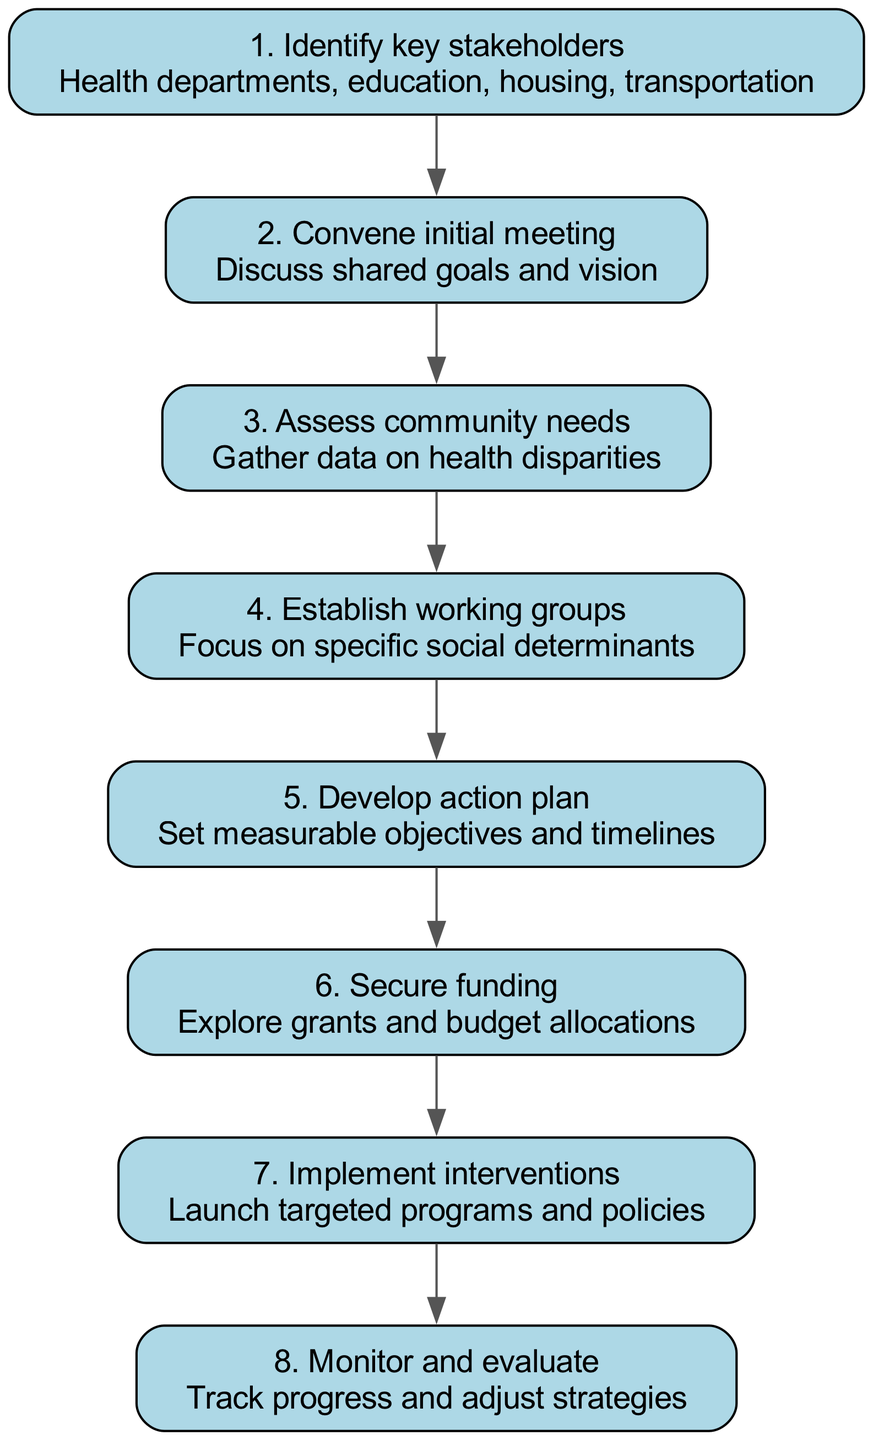What is the first step in the diagram? The first step, identified in the diagram, is labeled as step 1 and states "Identify key stakeholders."
Answer: Identify key stakeholders How many total steps are presented in the flow chart? The diagram outlines a total of 8 steps, from step 1 to step 8.
Answer: 8 What is the last step in the collaboration process? The last step is labeled as step 8, which states "Monitor and evaluate."
Answer: Monitor and evaluate What is the main focus of the third step? The third step focuses on "Assess community needs," which involves gathering data on health disparities.
Answer: Assess community needs Which step follows "Develop action plan"? The step that follows "Develop action plan" is step 6, which is "Secure funding."
Answer: Secure funding How does "Convene initial meeting" relate to "Identify key stakeholders"? The "Convene initial meeting" is the second step that directly follows "Identify key stakeholders" in the flow, indicating the progression from identifying to discussing shared goals.
Answer: Develop action plan What type of stakeholders are identified in the first step? The first step identifies various stakeholders including health departments, education, housing, and transportation.
Answer: Health departments, education, housing, transportation How is progress tracked in the final step? The final step involves "Monitor and evaluate," which describes the action of tracking progress and adjusting strategies accordingly.
Answer: Track progress and adjust strategies 